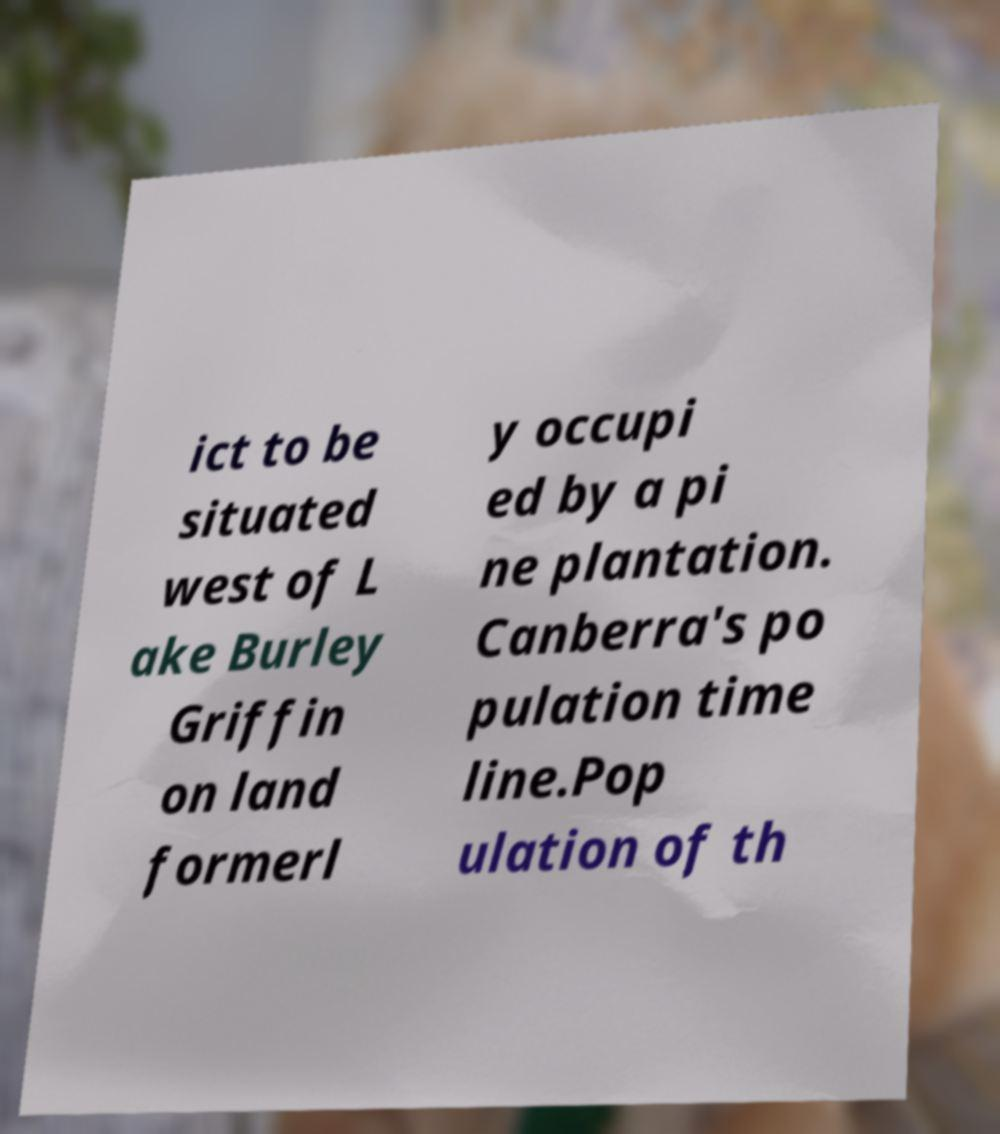Can you accurately transcribe the text from the provided image for me? ict to be situated west of L ake Burley Griffin on land formerl y occupi ed by a pi ne plantation. Canberra's po pulation time line.Pop ulation of th 